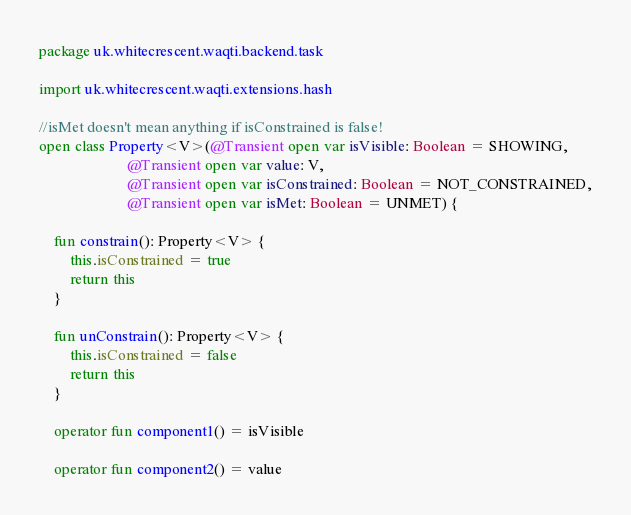<code> <loc_0><loc_0><loc_500><loc_500><_Kotlin_>package uk.whitecrescent.waqti.backend.task

import uk.whitecrescent.waqti.extensions.hash

//isMet doesn't mean anything if isConstrained is false!
open class Property<V>(@Transient open var isVisible: Boolean = SHOWING,
                       @Transient open var value: V,
                       @Transient open var isConstrained: Boolean = NOT_CONSTRAINED,
                       @Transient open var isMet: Boolean = UNMET) {

    fun constrain(): Property<V> {
        this.isConstrained = true
        return this
    }

    fun unConstrain(): Property<V> {
        this.isConstrained = false
        return this
    }

    operator fun component1() = isVisible

    operator fun component2() = value
</code> 